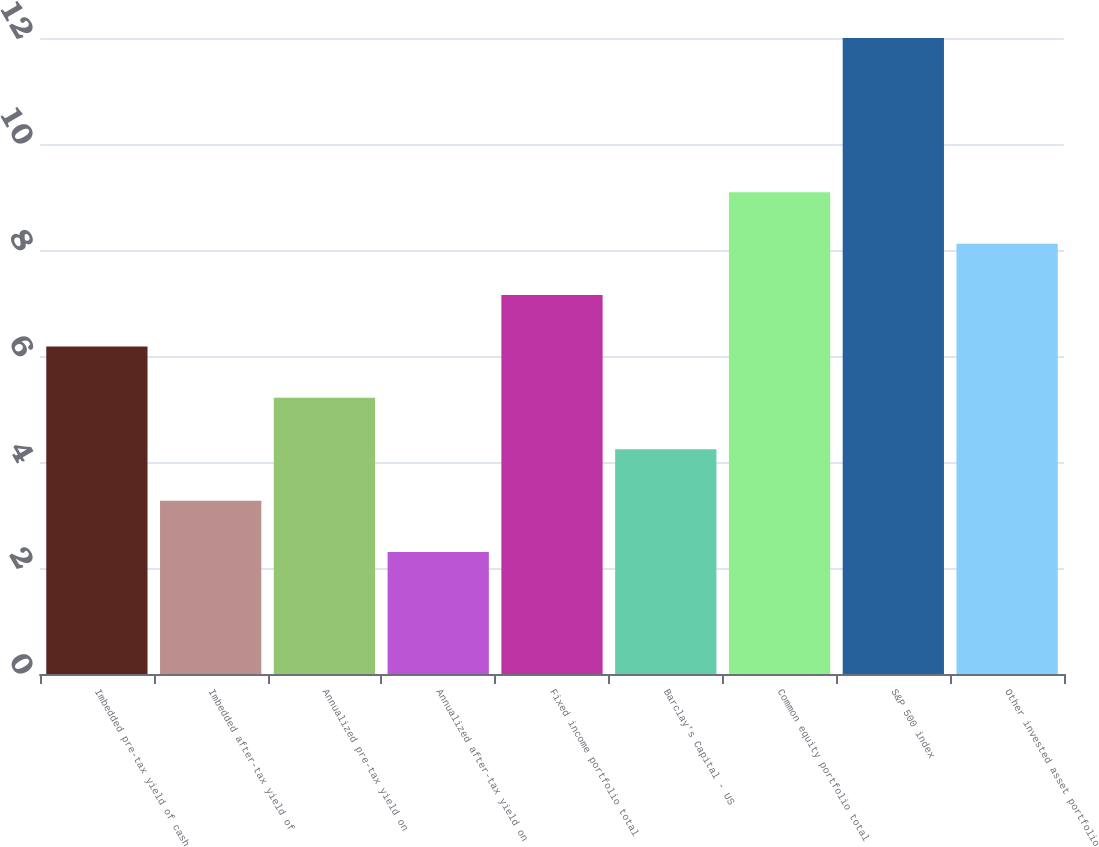Convert chart. <chart><loc_0><loc_0><loc_500><loc_500><bar_chart><fcel>Imbedded pre-tax yield of cash<fcel>Imbedded after-tax yield of<fcel>Annualized pre-tax yield on<fcel>Annualized after-tax yield on<fcel>Fixed income portfolio total<fcel>Barclay's Capital - US<fcel>Common equity portfolio total<fcel>S&P 500 index<fcel>Other invested asset portfolio<nl><fcel>6.18<fcel>3.27<fcel>5.21<fcel>2.3<fcel>7.15<fcel>4.24<fcel>9.09<fcel>12<fcel>8.12<nl></chart> 